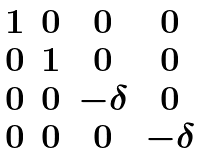<formula> <loc_0><loc_0><loc_500><loc_500>\begin{matrix} 1 & 0 & 0 & 0 \\ 0 & 1 & 0 & 0 \\ 0 & 0 & - \delta & 0 \\ 0 & 0 & 0 & - \delta \end{matrix}</formula> 